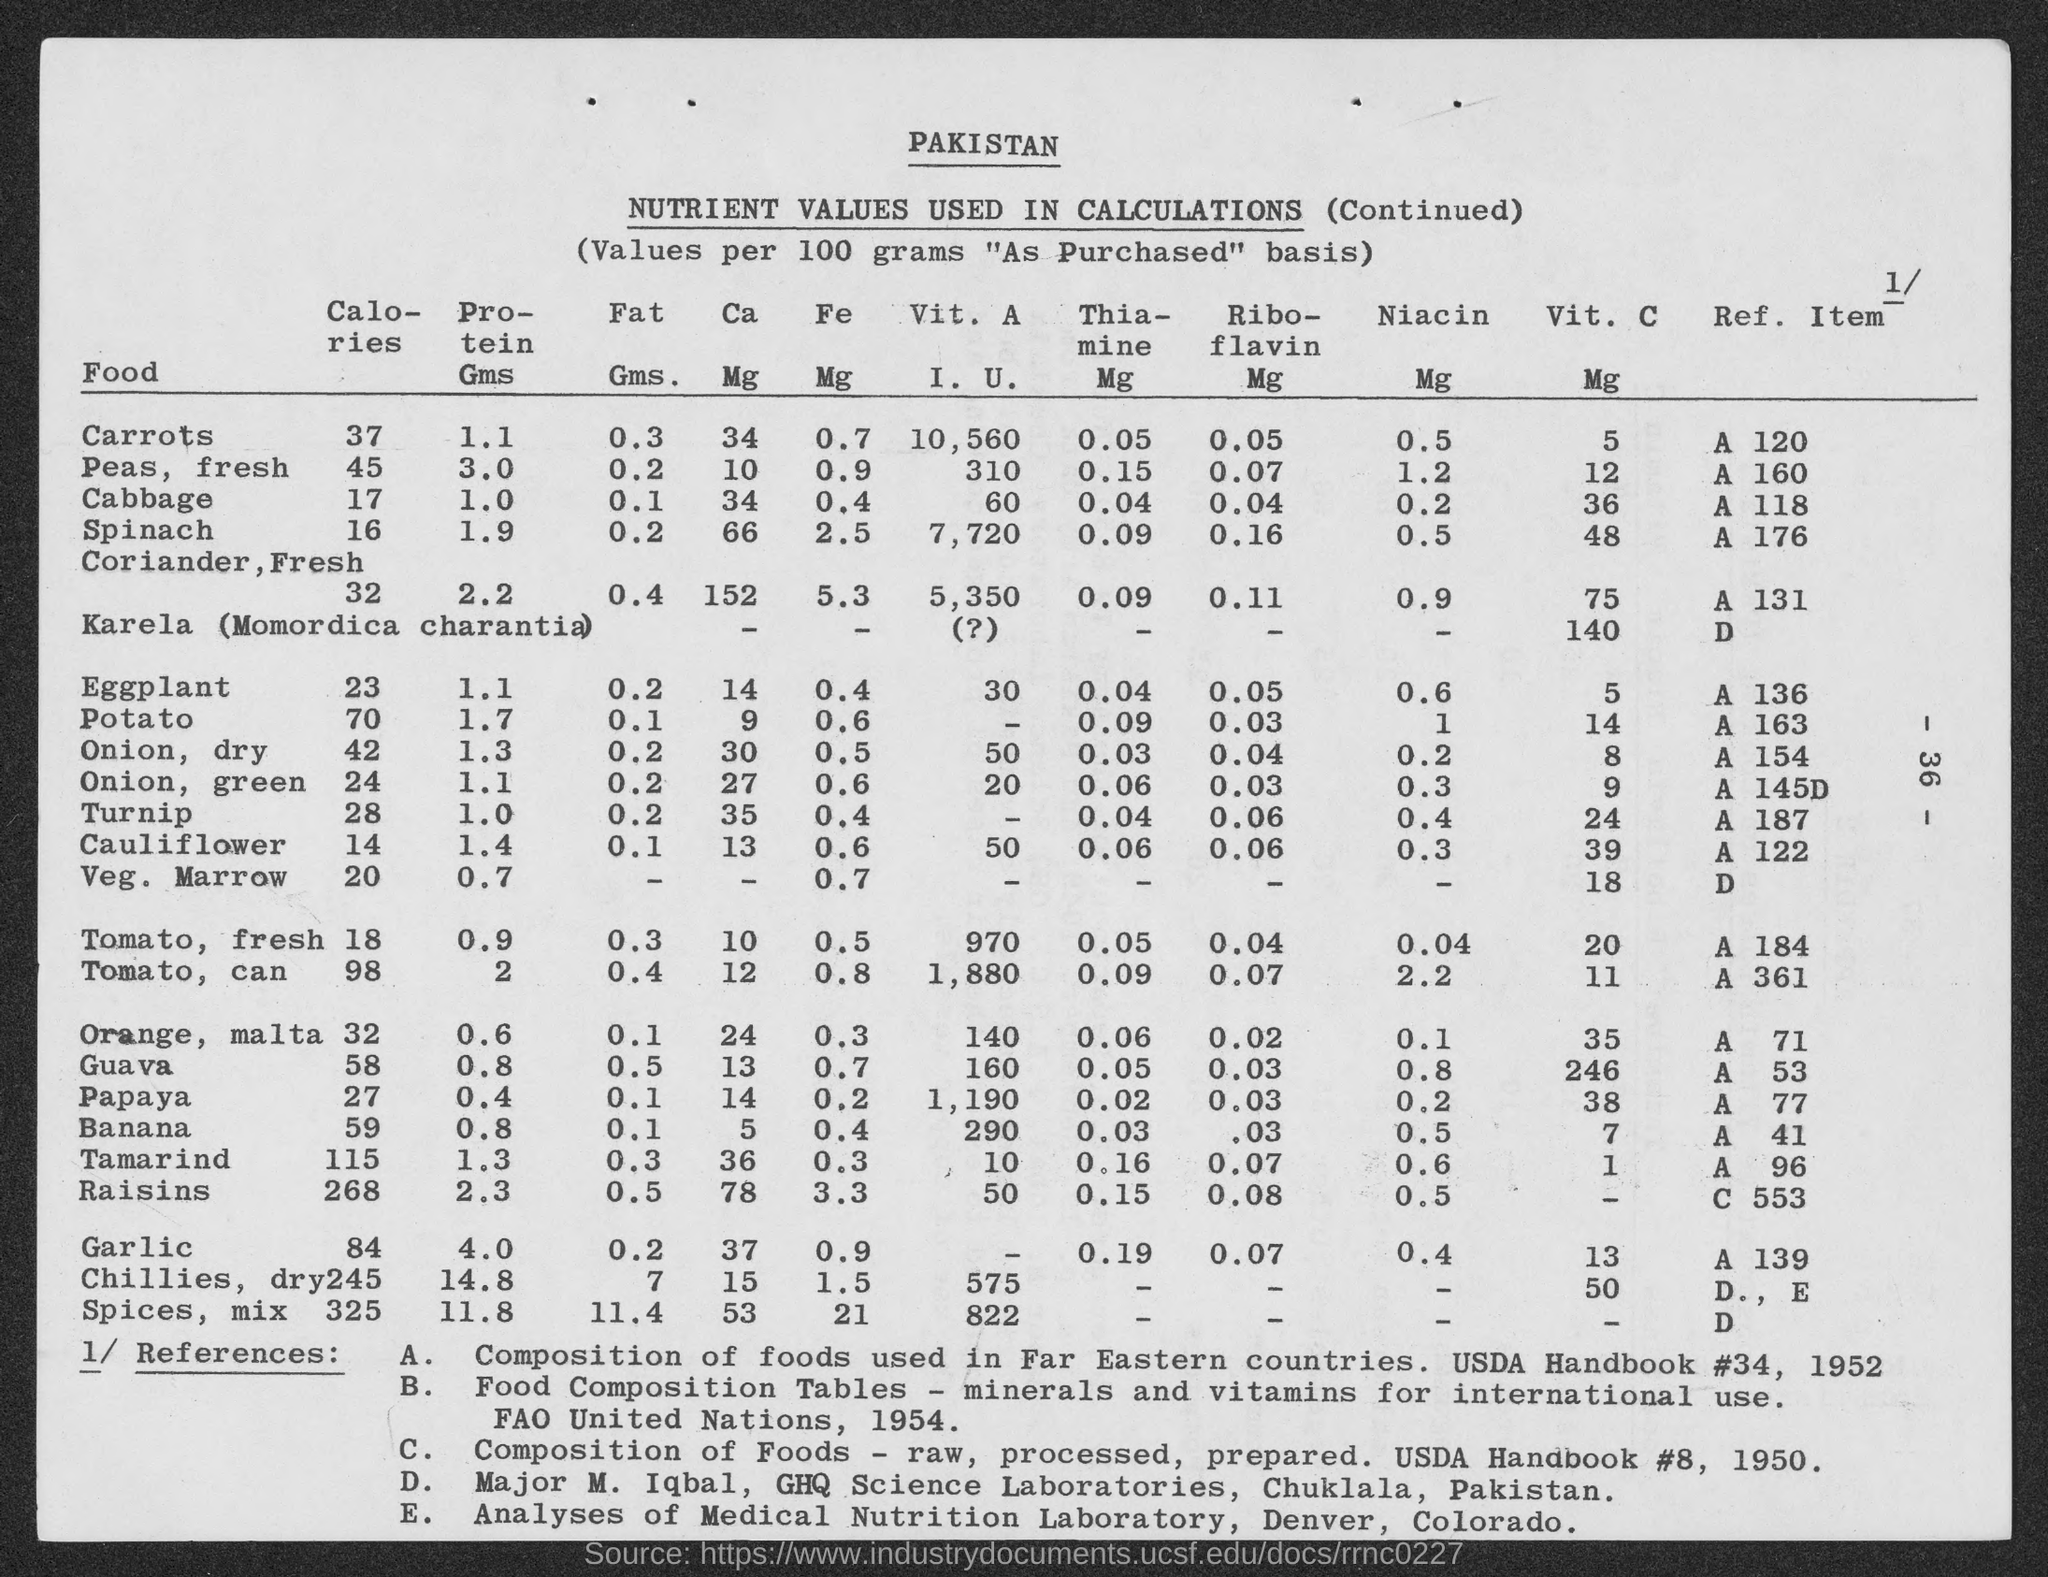Which country does the table represent?
Keep it short and to the point. Pakistan. What is the title of the table?
Give a very brief answer. Pakistan. What is the title of the first (left-most) column?
Your answer should be compact. Food. How many calories per 100 grams of Carrots?
Offer a terse response. 37. How many calories per 100 grams of Potato?
Your answer should be very brief. 70. How many calories per 100 grams of Raisins
Make the answer very short. 268. How many mg of Vit. C per 100 grams of Cauliflower?
Provide a short and direct response. 39. How many mg of Vit. C per 100 grams of Gauva?
Keep it short and to the point. 246. What does Reference E correspond to?
Give a very brief answer. Analyses of medical nutrition laboratory, denver, colorado. Ref. Item C 553 is mentioned against which Food item?
Keep it short and to the point. Raisins. 